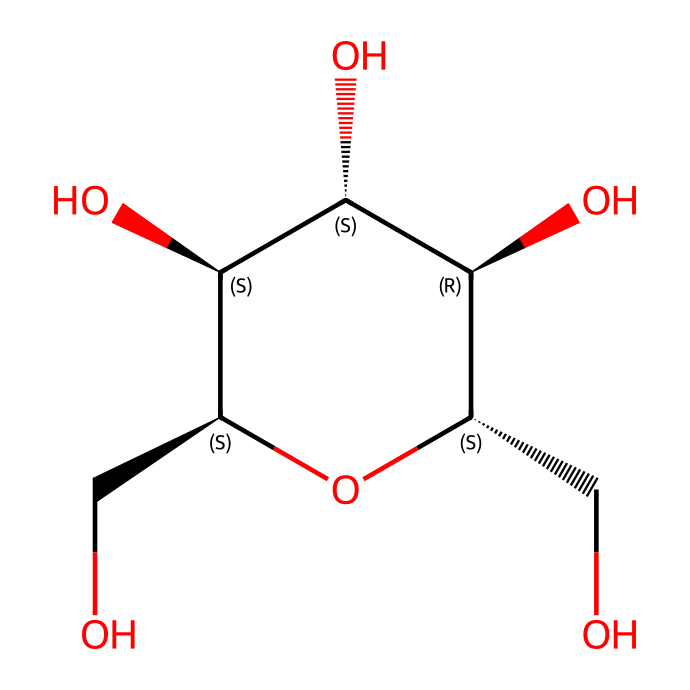How many carbon atoms are in this structure? By examining the SMILES representation, each "C" indicates a carbon atom. In this case, there are seven carbon atoms represented.
Answer: seven What functional groups can be identified in this structure? The structure contains hydroxyl (-OH) groups, which can be seen in the multiple "O" and "H" combinations. These groups indicate that it is a carbohydrate.
Answer: hydroxyl groups What is the main type of polymer represented by this chemical? The chemical structure, identified as starch, is a polysaccharide, which is a type of carbohydrate polymer.
Answer: polysaccharide How many hydroxyl groups exist in this starch molecule? Counting the number of "O" atoms linked to "H" in the chemical, there are four hydroxyl groups.
Answer: four Is this carbohydrate a simple sugar or complex carbohydrate? The structure reveals multiple repeating units, indicative of a complex carbohydrate.
Answer: complex carbohydrate What type of linkage characterizes the bonds in this starch molecule? In analyzing the structure, the bonds connecting the glucose units are glycosidic linkages, a characteristic of polysaccharides like starch.
Answer: glycosidic linkages 